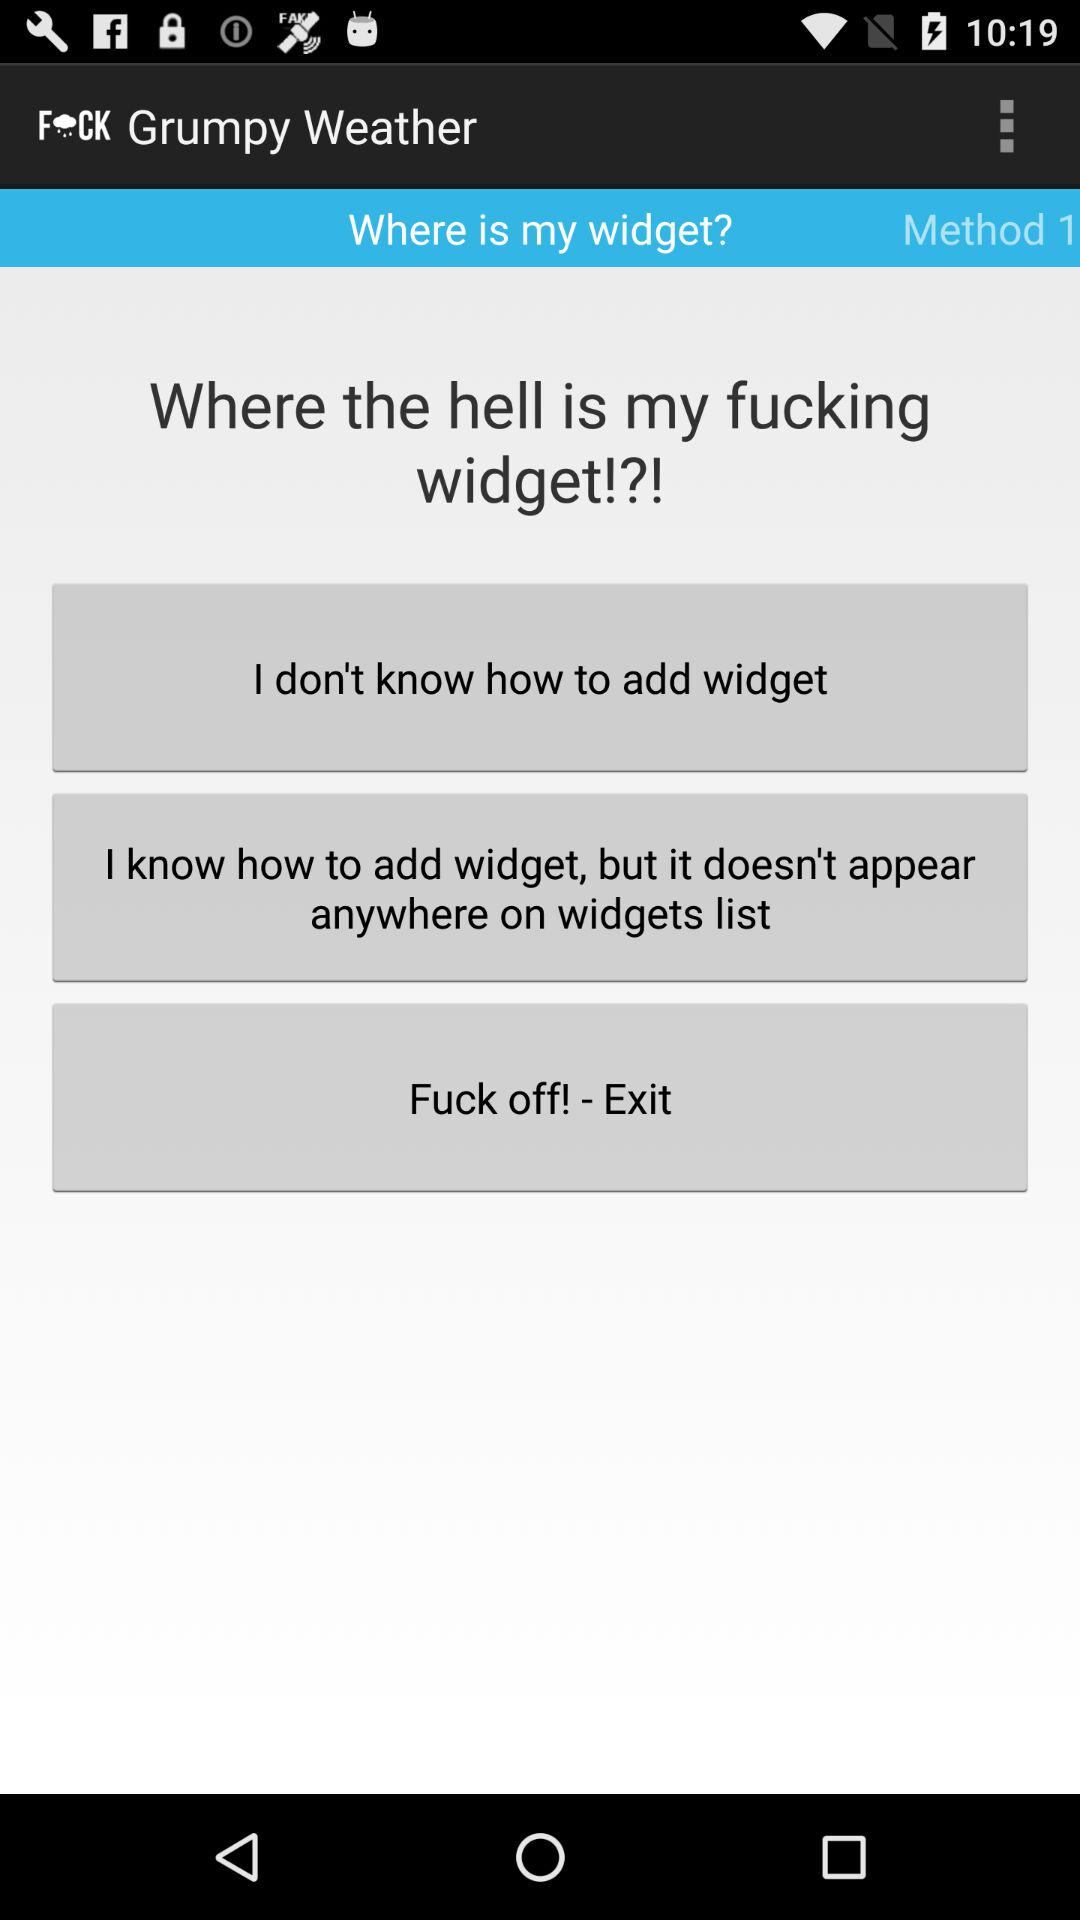What is the name of the application? The name of the application is "Grumpy Weather". 